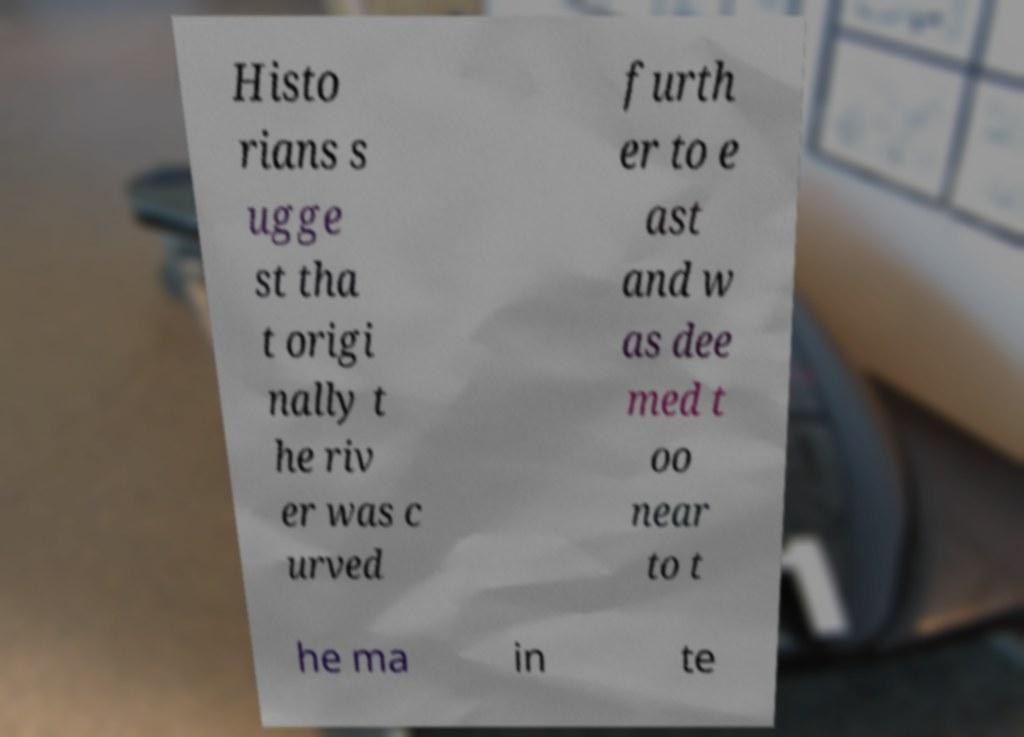What messages or text are displayed in this image? I need them in a readable, typed format. Histo rians s ugge st tha t origi nally t he riv er was c urved furth er to e ast and w as dee med t oo near to t he ma in te 